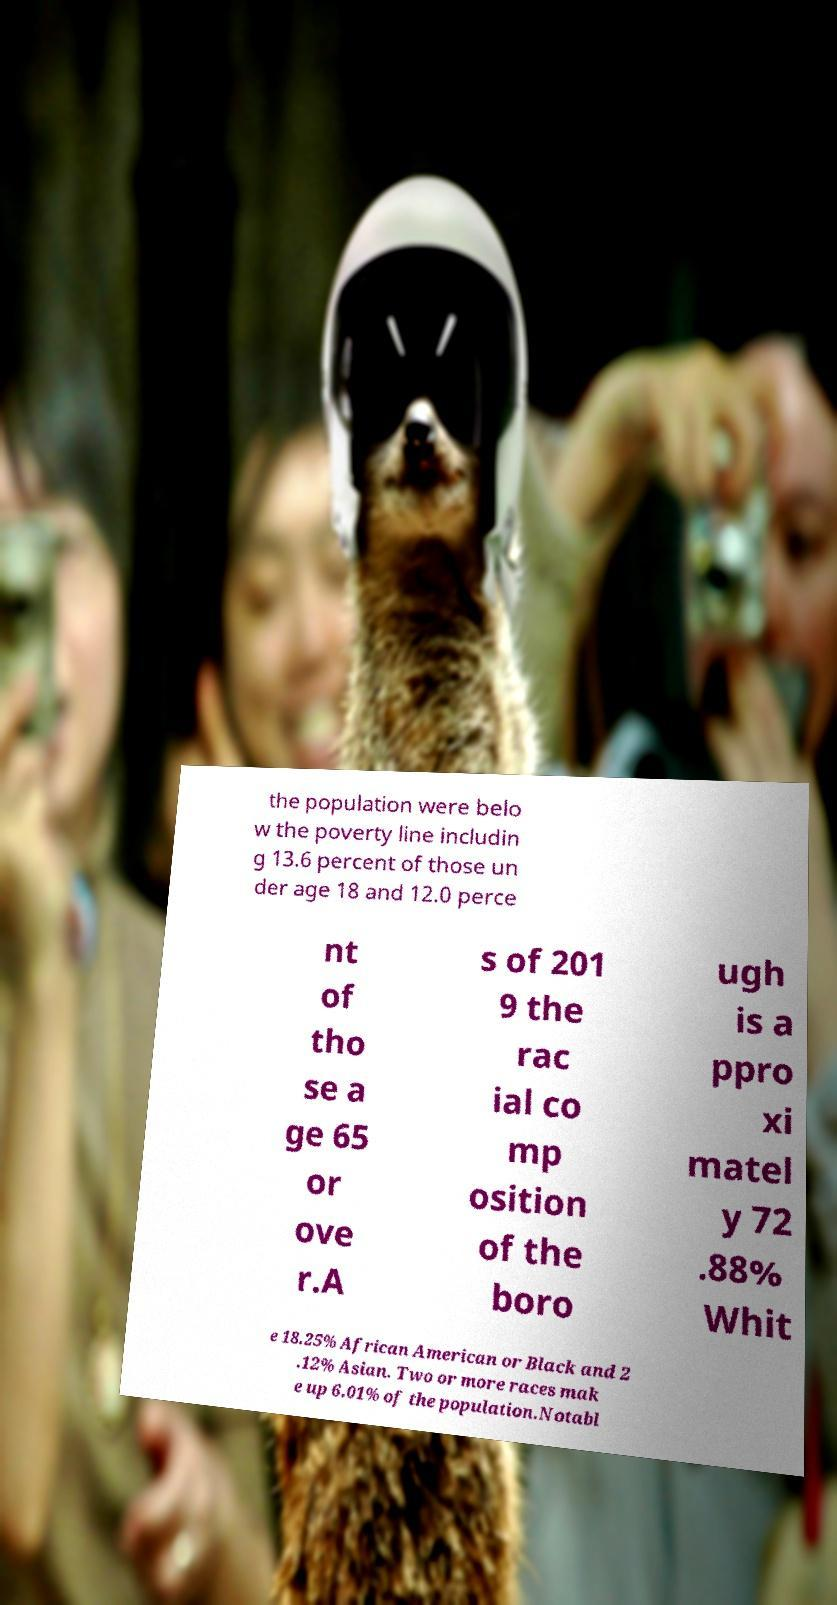Please read and relay the text visible in this image. What does it say? the population were belo w the poverty line includin g 13.6 percent of those un der age 18 and 12.0 perce nt of tho se a ge 65 or ove r.A s of 201 9 the rac ial co mp osition of the boro ugh is a ppro xi matel y 72 .88% Whit e 18.25% African American or Black and 2 .12% Asian. Two or more races mak e up 6.01% of the population.Notabl 